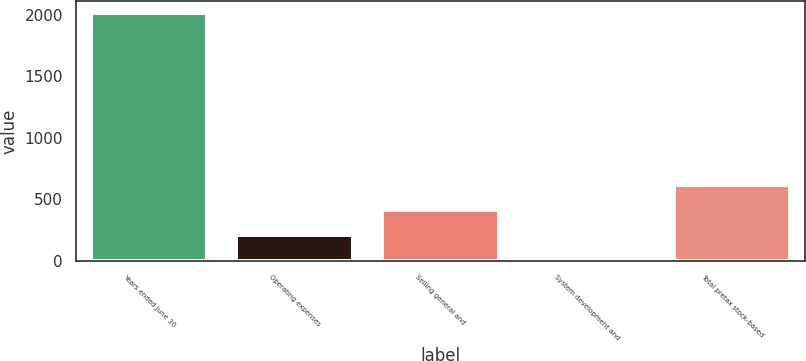Convert chart. <chart><loc_0><loc_0><loc_500><loc_500><bar_chart><fcel>Years ended June 30<fcel>Operating expenses<fcel>Selling general and<fcel>System development and<fcel>Total pretax stock-based<nl><fcel>2013<fcel>214.35<fcel>414.2<fcel>14.5<fcel>614.05<nl></chart> 